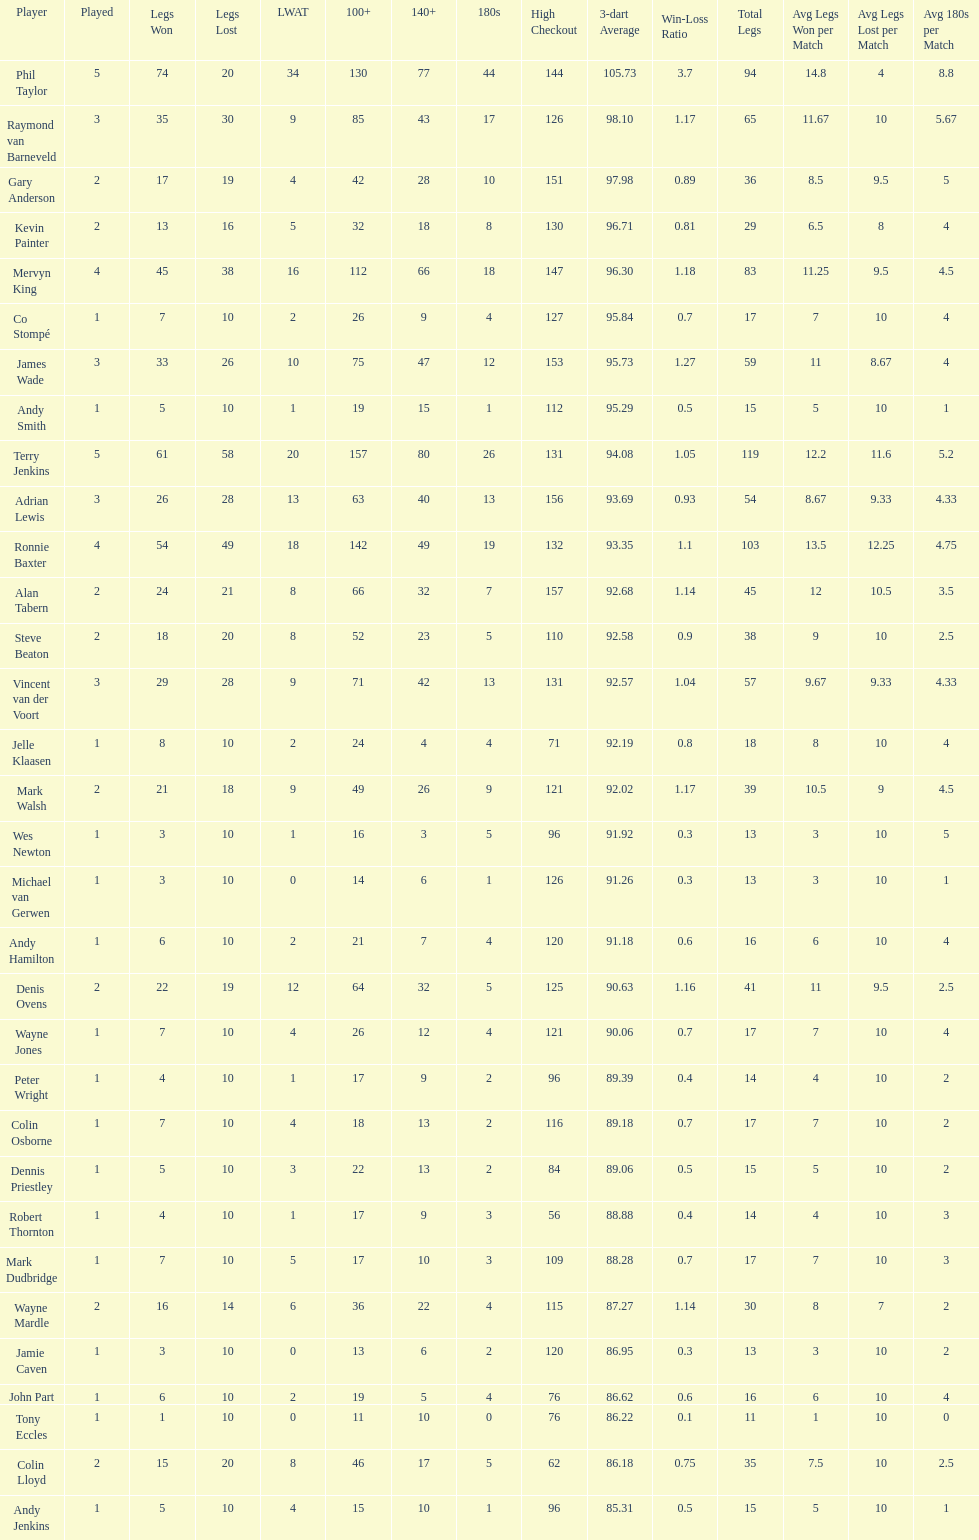What is the name of the next player after mark walsh? Wes Newton. 